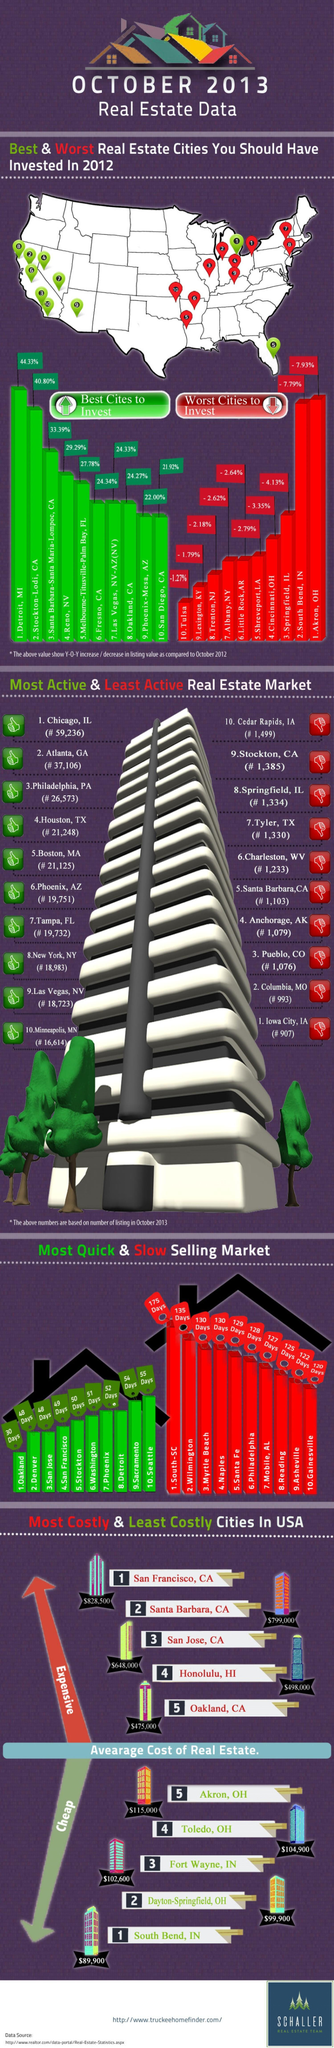What is the percentage for the third best city to invest?
Answer the question with a short phrase. 33.39% Which is the second best city to invest? Stockton-Lodi, CA 